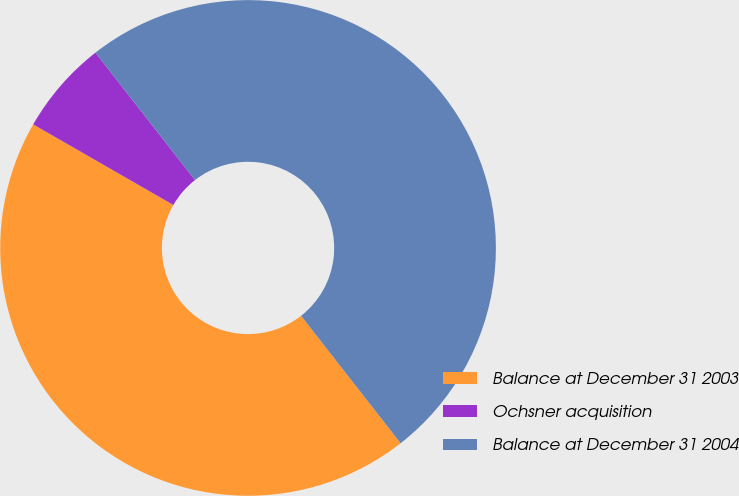Convert chart. <chart><loc_0><loc_0><loc_500><loc_500><pie_chart><fcel>Balance at December 31 2003<fcel>Ochsner acquisition<fcel>Balance at December 31 2004<nl><fcel>43.86%<fcel>6.14%<fcel>50.0%<nl></chart> 